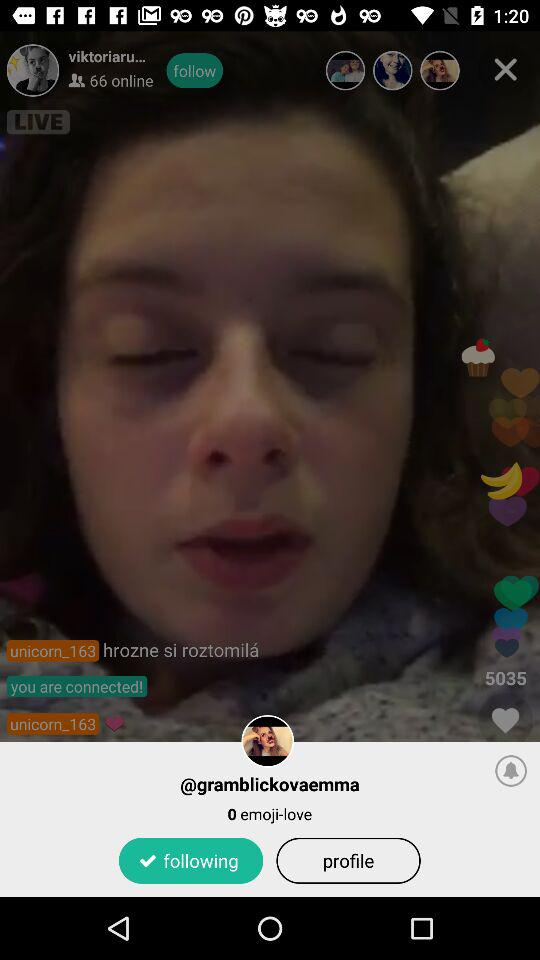How many users are online? There are 66 users online. 